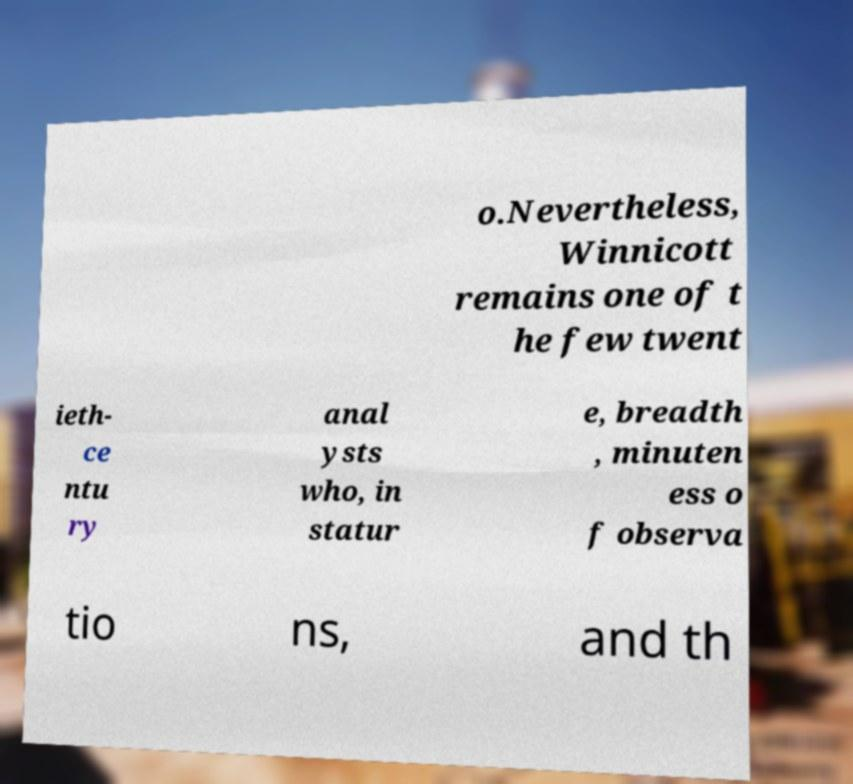Can you read and provide the text displayed in the image?This photo seems to have some interesting text. Can you extract and type it out for me? o.Nevertheless, Winnicott remains one of t he few twent ieth- ce ntu ry anal ysts who, in statur e, breadth , minuten ess o f observa tio ns, and th 